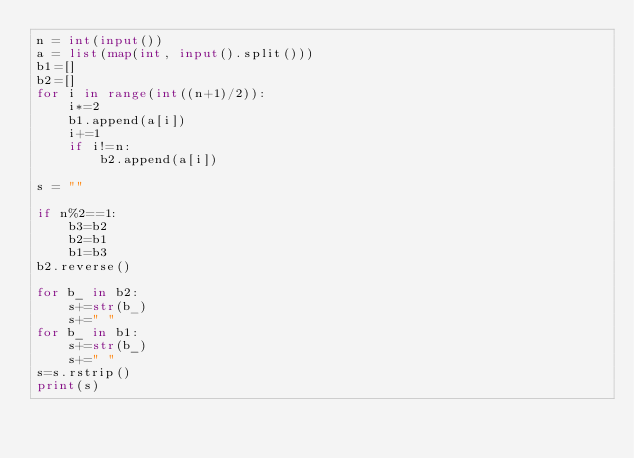<code> <loc_0><loc_0><loc_500><loc_500><_Python_>n = int(input())
a = list(map(int, input().split()))
b1=[]
b2=[]
for i in range(int((n+1)/2)):
    i*=2
    b1.append(a[i])
    i+=1
    if i!=n:
        b2.append(a[i])

s = ""

if n%2==1:
    b3=b2
    b2=b1
    b1=b3
b2.reverse()

for b_ in b2:
    s+=str(b_)
    s+=" "
for b_ in b1:
    s+=str(b_)
    s+=" "
s=s.rstrip()
print(s)
</code> 